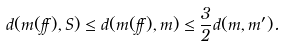<formula> <loc_0><loc_0><loc_500><loc_500>d ( m ( \alpha ) , S ) \leq d ( m ( \alpha ) , m ) \leq \frac { 3 } { 2 } d ( m , m ^ { \prime } ) .</formula> 